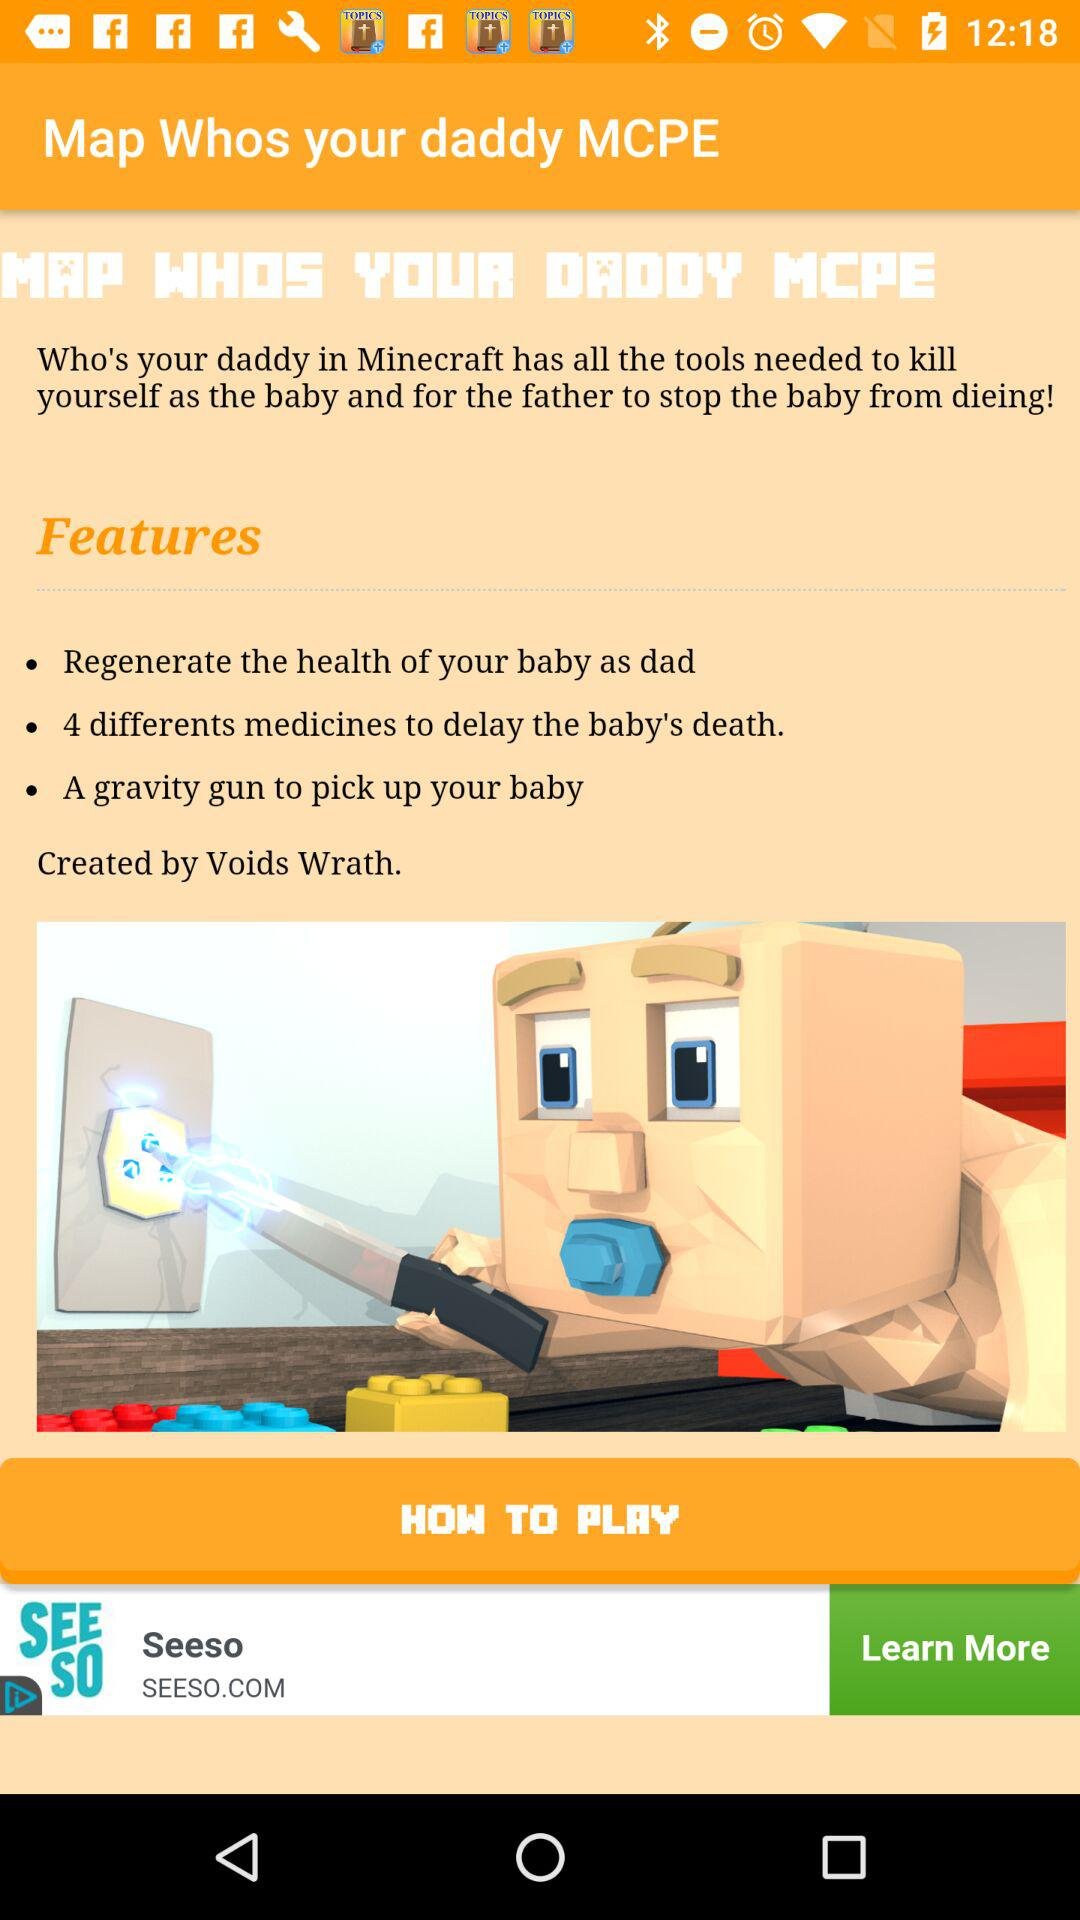What is the name of the game? The name of the game is "Map Whos your daddy MCPE". 